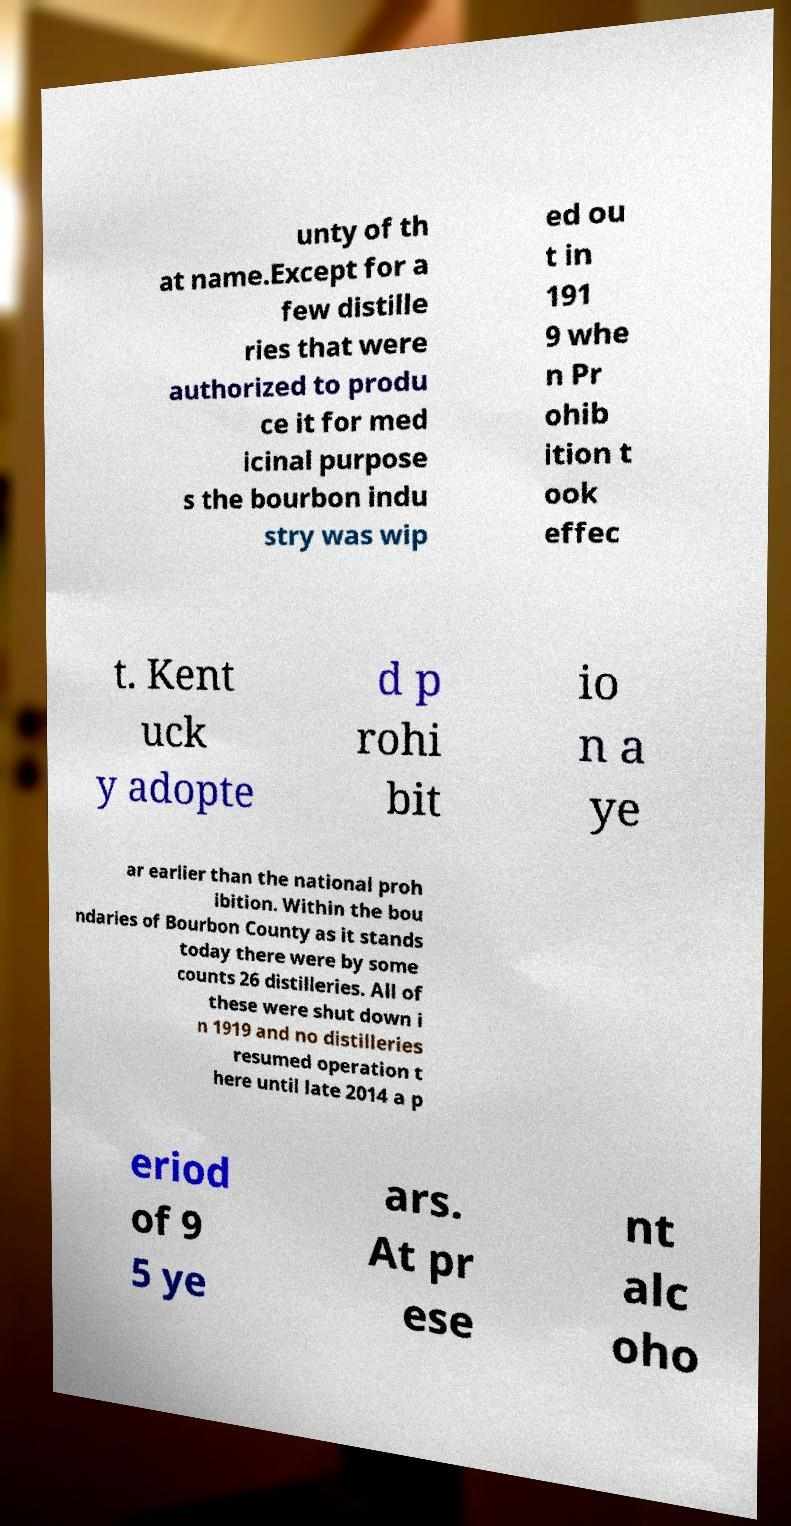There's text embedded in this image that I need extracted. Can you transcribe it verbatim? unty of th at name.Except for a few distille ries that were authorized to produ ce it for med icinal purpose s the bourbon indu stry was wip ed ou t in 191 9 whe n Pr ohib ition t ook effec t. Kent uck y adopte d p rohi bit io n a ye ar earlier than the national proh ibition. Within the bou ndaries of Bourbon County as it stands today there were by some counts 26 distilleries. All of these were shut down i n 1919 and no distilleries resumed operation t here until late 2014 a p eriod of 9 5 ye ars. At pr ese nt alc oho 